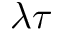<formula> <loc_0><loc_0><loc_500><loc_500>\lambda \tau</formula> 